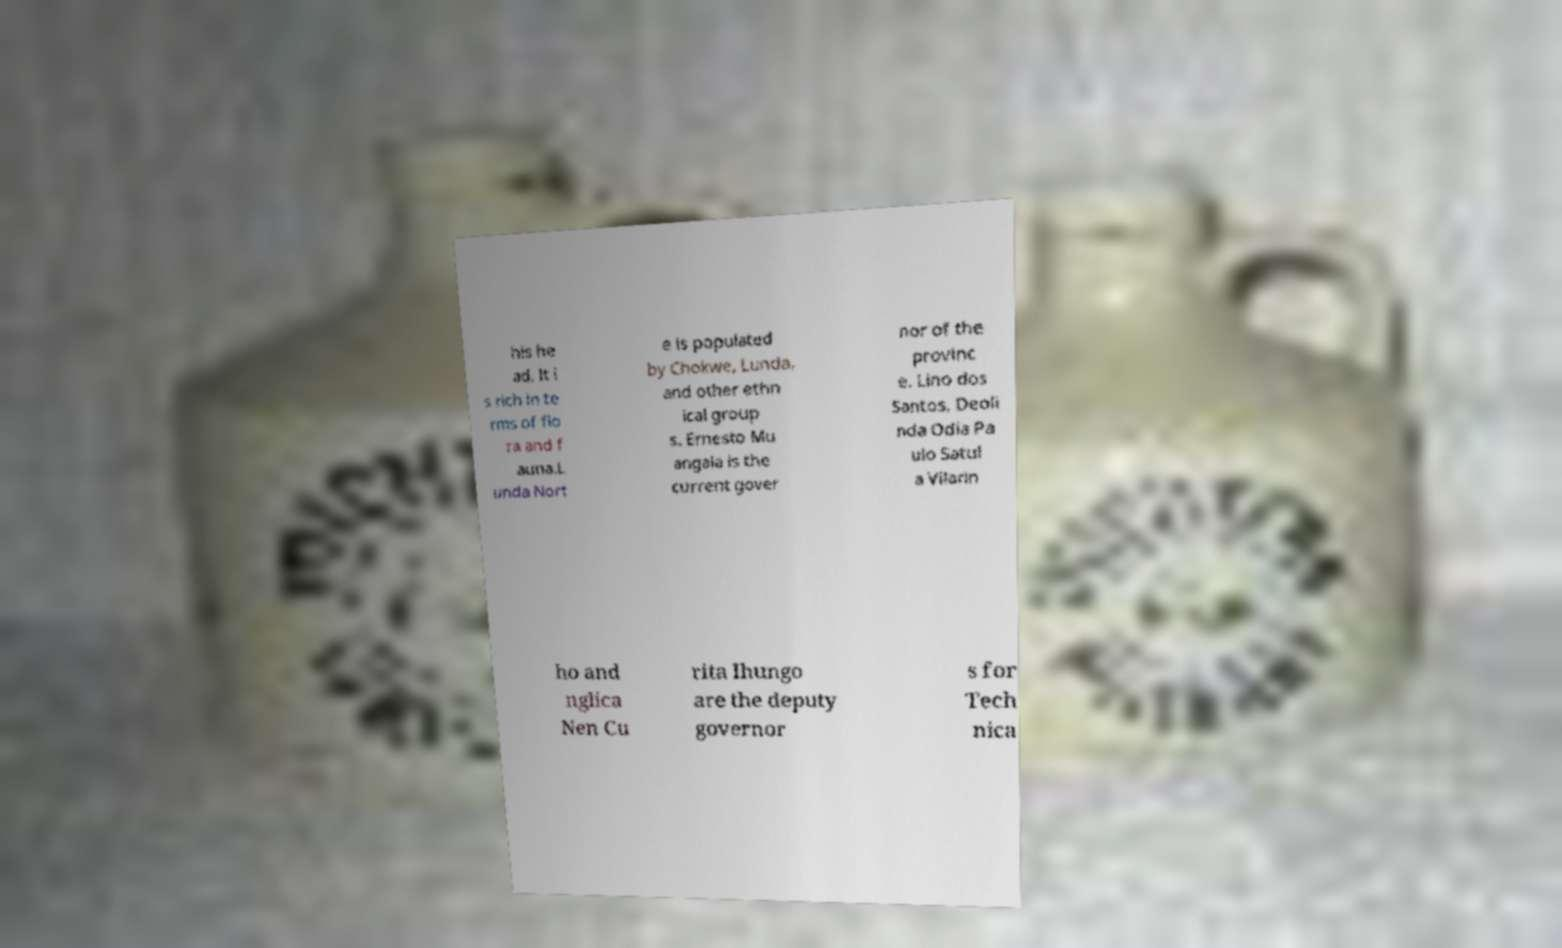Could you assist in decoding the text presented in this image and type it out clearly? his he ad. It i s rich in te rms of flo ra and f auna.L unda Nort e is populated by Chokwe, Lunda, and other ethn ical group s. Ernesto Mu angala is the current gover nor of the provinc e. Lino dos Santos, Deoli nda Odia Pa ulo Satul a Vilarin ho and nglica Nen Cu rita Ihungo are the deputy governor s for Tech nica 